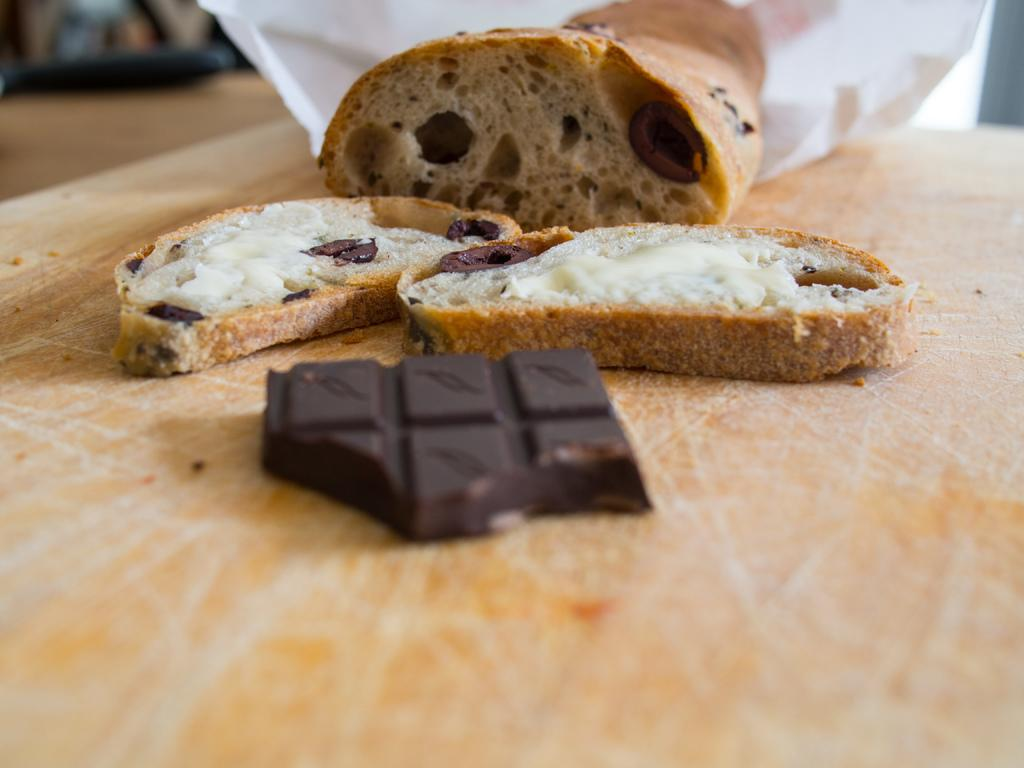What is the main food item on the wooden surface in the image? There is a chocolate on the wooden surface. What accompanies the chocolate on the wooden surface? There are bread slices with cream on the wooden surface. Are there any other items on the wooden surface? Yes, there are other items on the wooden surface. What can be seen in the background of the image? There is a white thing in the background. What type of dress is hanging on the oven in the image? There is no dress or oven present in the image. How many oranges are visible on the wooden surface? There are no oranges visible on the wooden surface; the image features a chocolate and bread slices with cream. 